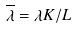<formula> <loc_0><loc_0><loc_500><loc_500>\overline { \lambda } = \lambda K / L</formula> 